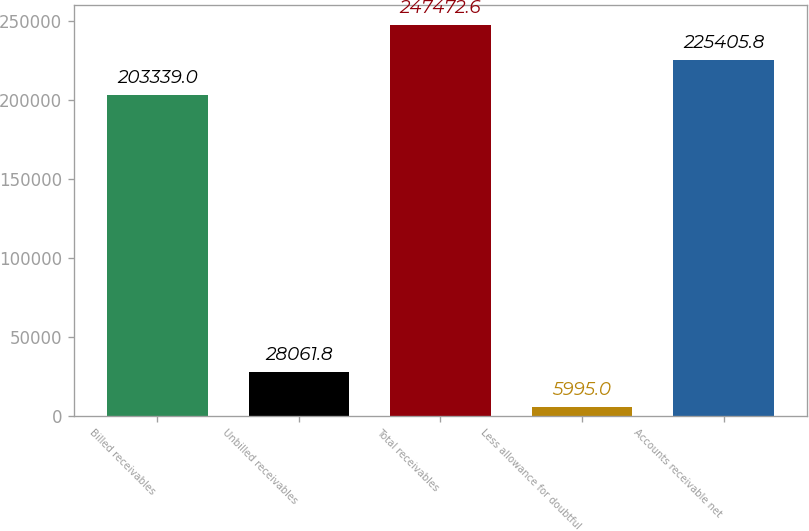Convert chart to OTSL. <chart><loc_0><loc_0><loc_500><loc_500><bar_chart><fcel>Billed receivables<fcel>Unbilled receivables<fcel>Total receivables<fcel>Less allowance for doubtful<fcel>Accounts receivable net<nl><fcel>203339<fcel>28061.8<fcel>247473<fcel>5995<fcel>225406<nl></chart> 